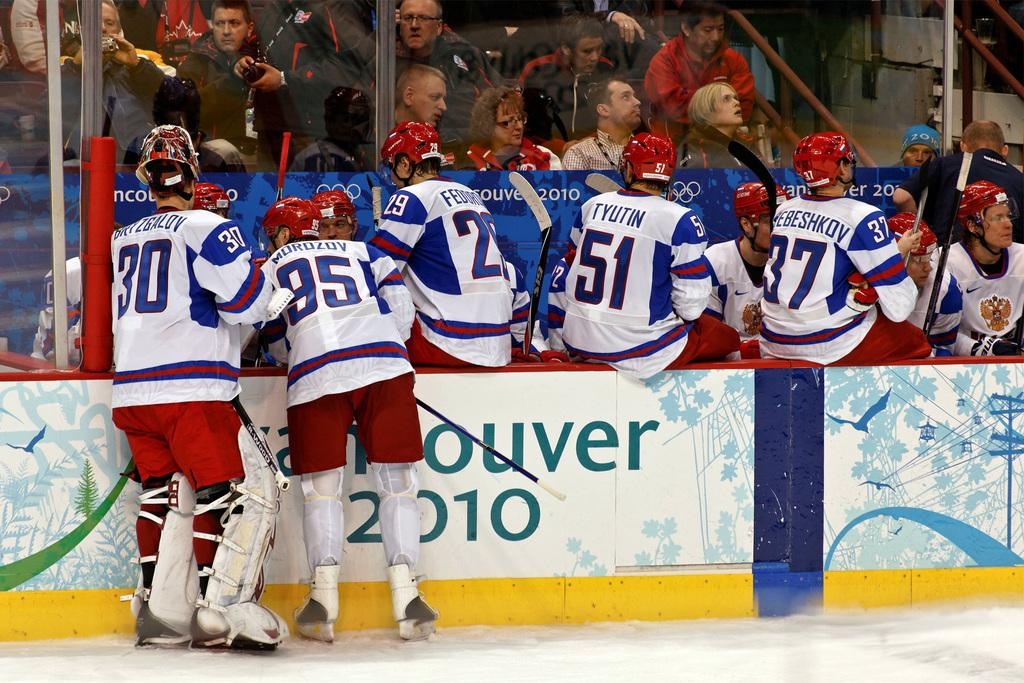Provide a one-sentence caption for the provided image. Alexei Morozov and his hockey teammates huddle in the pen during a 2010 game. 